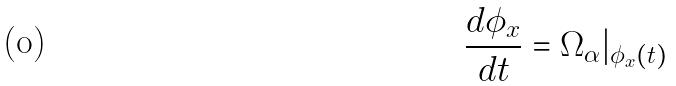<formula> <loc_0><loc_0><loc_500><loc_500>\frac { d \phi _ { x } } { d t } = \Omega _ { \alpha } | _ { \phi _ { x } ( t ) }</formula> 